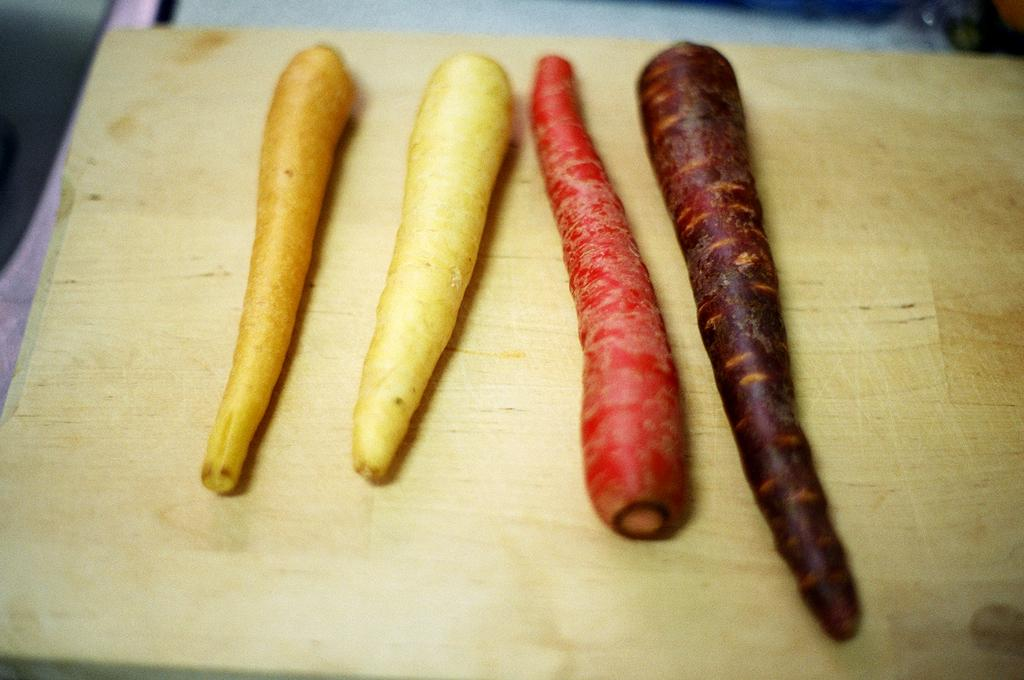What type of vegetable is present in the image? There are carrots in the image. What colors can be seen on the carrots? The carrots are in cream, red, brown, and white colors. What is the background of the carrots in the image? The carrots are on a brown color board. How many people are in the crowd near the lake in the image? There is no crowd or lake present in the image; it only features carrots on a brown color board. What sound does the whistle make in the image? There is no whistle present in the image. 